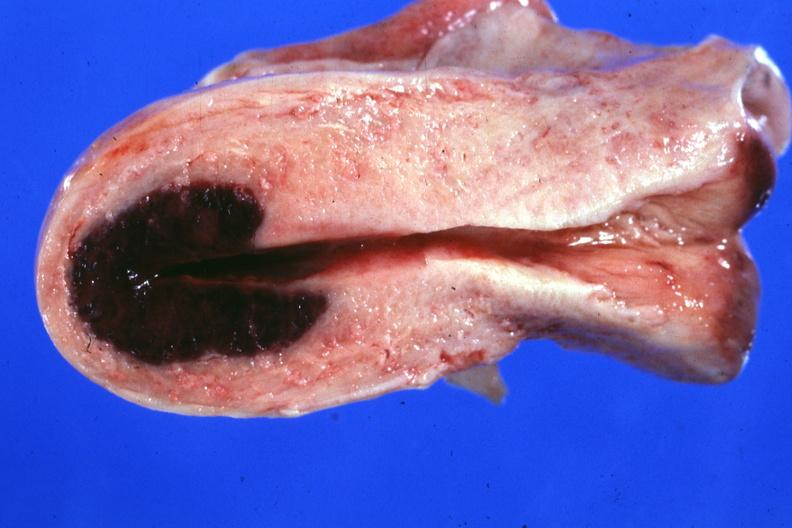does this image show localized lesion in dome of uterus said to have adenosis adenomyosis hemorrhage probably due to shock?
Answer the question using a single word or phrase. Yes 